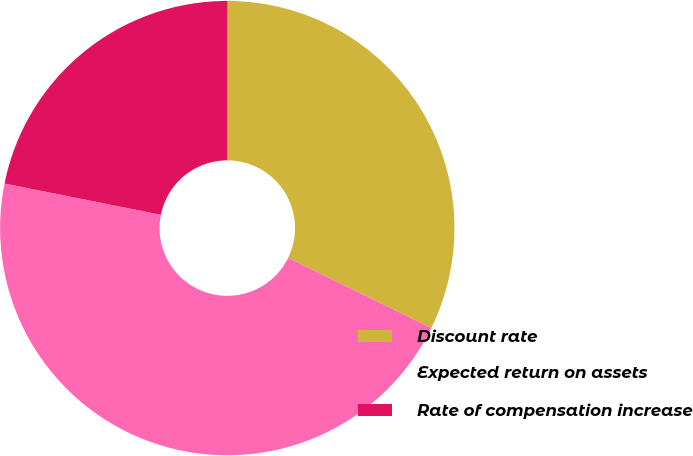Convert chart. <chart><loc_0><loc_0><loc_500><loc_500><pie_chart><fcel>Discount rate<fcel>Expected return on assets<fcel>Rate of compensation increase<nl><fcel>32.24%<fcel>45.9%<fcel>21.86%<nl></chart> 